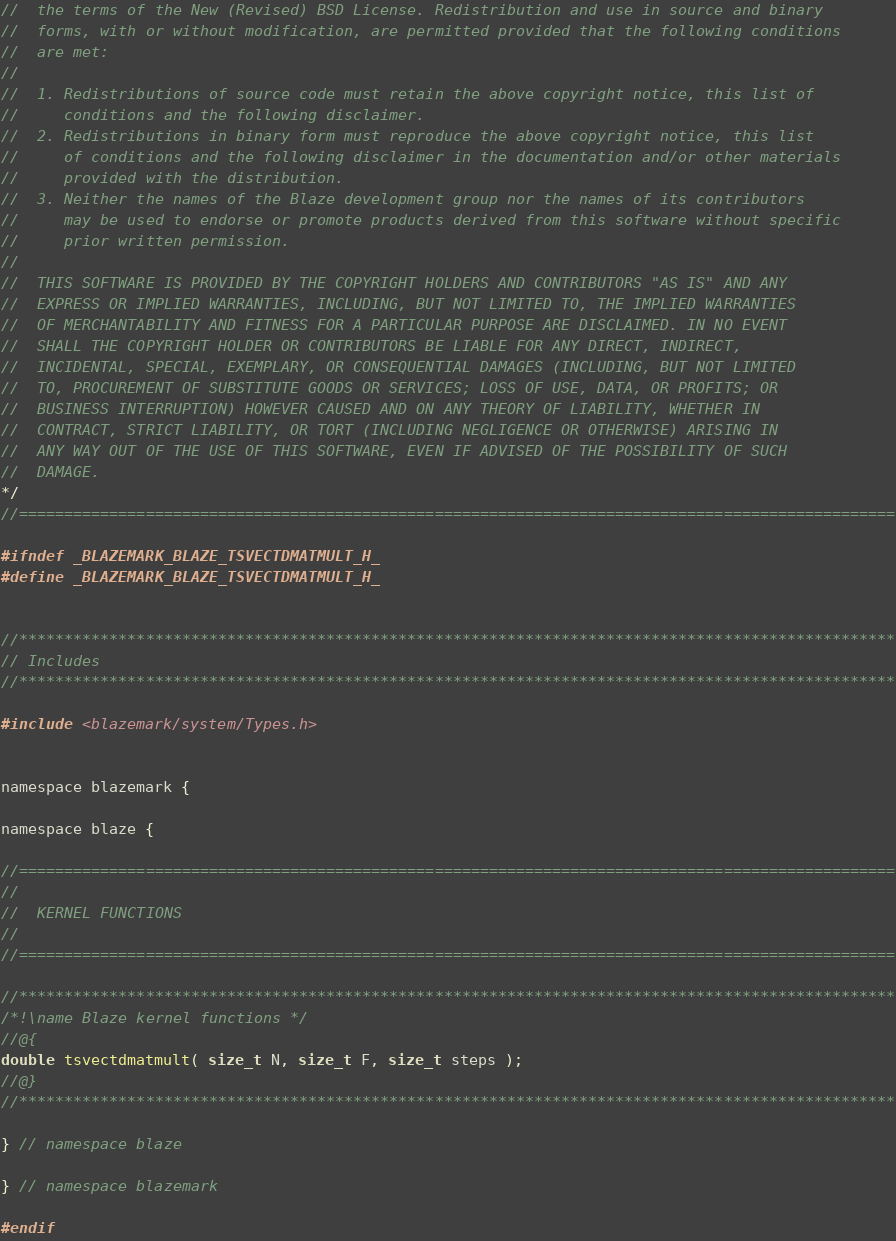Convert code to text. <code><loc_0><loc_0><loc_500><loc_500><_C_>//  the terms of the New (Revised) BSD License. Redistribution and use in source and binary
//  forms, with or without modification, are permitted provided that the following conditions
//  are met:
//
//  1. Redistributions of source code must retain the above copyright notice, this list of
//     conditions and the following disclaimer.
//  2. Redistributions in binary form must reproduce the above copyright notice, this list
//     of conditions and the following disclaimer in the documentation and/or other materials
//     provided with the distribution.
//  3. Neither the names of the Blaze development group nor the names of its contributors
//     may be used to endorse or promote products derived from this software without specific
//     prior written permission.
//
//  THIS SOFTWARE IS PROVIDED BY THE COPYRIGHT HOLDERS AND CONTRIBUTORS "AS IS" AND ANY
//  EXPRESS OR IMPLIED WARRANTIES, INCLUDING, BUT NOT LIMITED TO, THE IMPLIED WARRANTIES
//  OF MERCHANTABILITY AND FITNESS FOR A PARTICULAR PURPOSE ARE DISCLAIMED. IN NO EVENT
//  SHALL THE COPYRIGHT HOLDER OR CONTRIBUTORS BE LIABLE FOR ANY DIRECT, INDIRECT,
//  INCIDENTAL, SPECIAL, EXEMPLARY, OR CONSEQUENTIAL DAMAGES (INCLUDING, BUT NOT LIMITED
//  TO, PROCUREMENT OF SUBSTITUTE GOODS OR SERVICES; LOSS OF USE, DATA, OR PROFITS; OR
//  BUSINESS INTERRUPTION) HOWEVER CAUSED AND ON ANY THEORY OF LIABILITY, WHETHER IN
//  CONTRACT, STRICT LIABILITY, OR TORT (INCLUDING NEGLIGENCE OR OTHERWISE) ARISING IN
//  ANY WAY OUT OF THE USE OF THIS SOFTWARE, EVEN IF ADVISED OF THE POSSIBILITY OF SUCH
//  DAMAGE.
*/
//=================================================================================================

#ifndef _BLAZEMARK_BLAZE_TSVECTDMATMULT_H_
#define _BLAZEMARK_BLAZE_TSVECTDMATMULT_H_


//*************************************************************************************************
// Includes
//*************************************************************************************************

#include <blazemark/system/Types.h>


namespace blazemark {

namespace blaze {

//=================================================================================================
//
//  KERNEL FUNCTIONS
//
//=================================================================================================

//*************************************************************************************************
/*!\name Blaze kernel functions */
//@{
double tsvectdmatmult( size_t N, size_t F, size_t steps );
//@}
//*************************************************************************************************

} // namespace blaze

} // namespace blazemark

#endif
</code> 